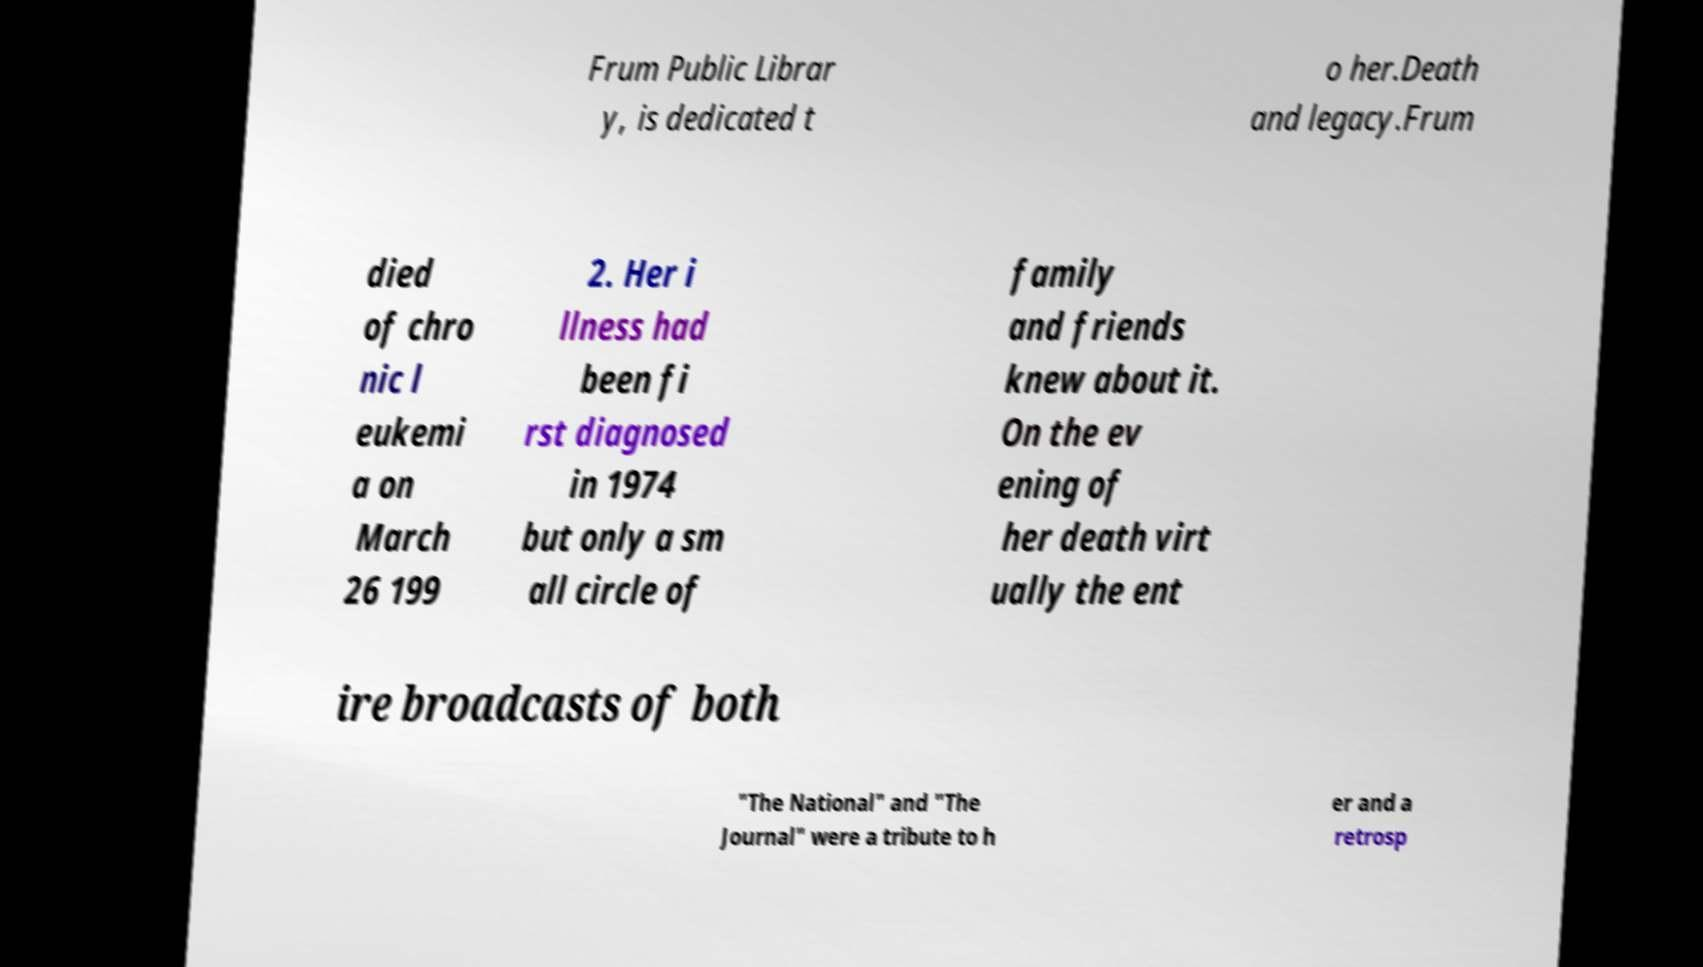Could you extract and type out the text from this image? Frum Public Librar y, is dedicated t o her.Death and legacy.Frum died of chro nic l eukemi a on March 26 199 2. Her i llness had been fi rst diagnosed in 1974 but only a sm all circle of family and friends knew about it. On the ev ening of her death virt ually the ent ire broadcasts of both "The National" and "The Journal" were a tribute to h er and a retrosp 